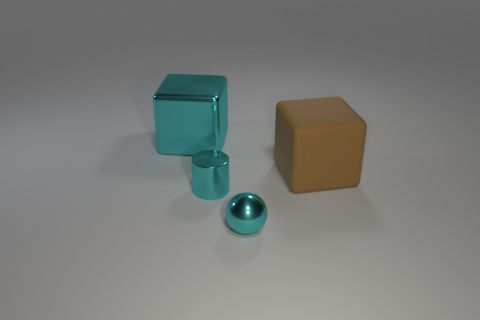There is a brown block; does it have the same size as the cyan shiny thing that is to the right of the small metal cylinder?
Offer a very short reply. No. What is the size of the other object that is the same shape as the brown thing?
Keep it short and to the point. Large. There is a big thing in front of the cyan thing behind the brown cube; how many metallic spheres are to the right of it?
Offer a very short reply. 0. How many cubes are either large brown things or cyan objects?
Ensure brevity in your answer.  2. There is a metal object that is behind the large thing that is in front of the object that is behind the large brown matte cube; what color is it?
Give a very brief answer. Cyan. What number of other objects are the same size as the brown cube?
Your response must be concise. 1. What color is the other thing that is the same shape as the large cyan object?
Your answer should be compact. Brown. There is a small ball that is made of the same material as the big cyan thing; what is its color?
Provide a succinct answer. Cyan. Is the number of cyan things that are right of the large cyan metal block the same as the number of cyan metal cylinders?
Ensure brevity in your answer.  No. There is a thing that is behind the rubber object; is its size the same as the large brown rubber object?
Your response must be concise. Yes. 